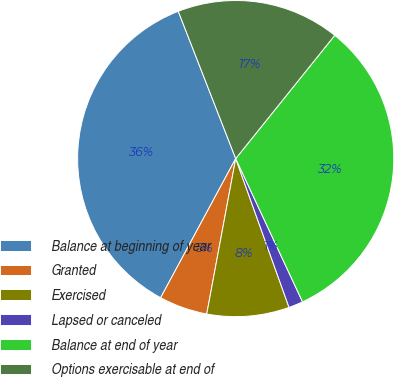<chart> <loc_0><loc_0><loc_500><loc_500><pie_chart><fcel>Balance at beginning of year<fcel>Granted<fcel>Exercised<fcel>Lapsed or canceled<fcel>Balance at end of year<fcel>Options exercisable at end of<nl><fcel>36.21%<fcel>4.94%<fcel>8.41%<fcel>1.47%<fcel>32.28%<fcel>16.69%<nl></chart> 